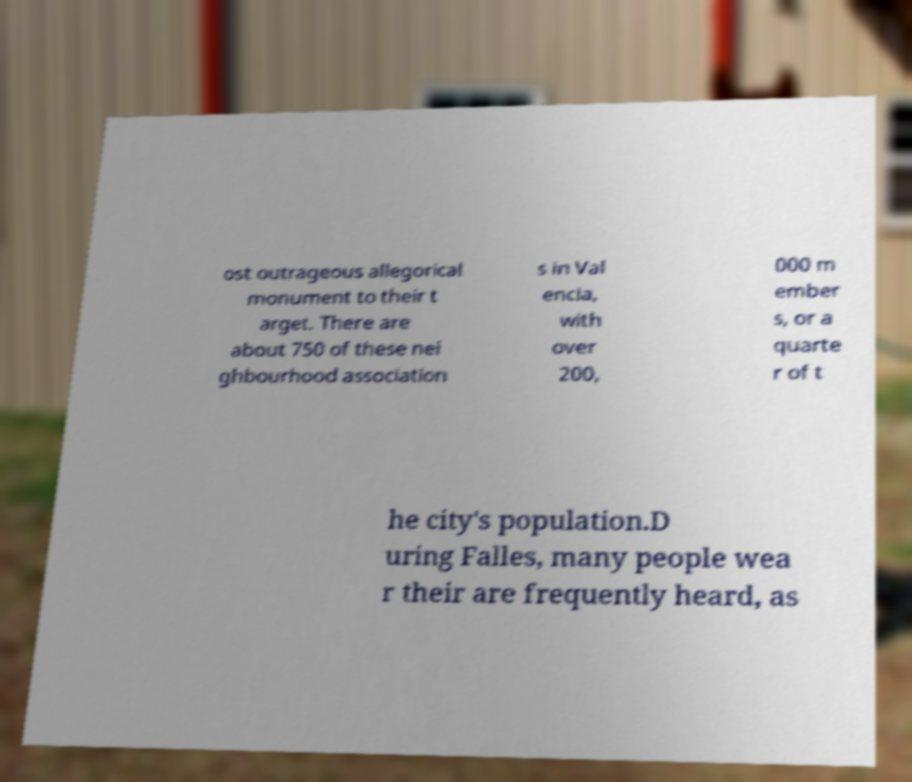Could you extract and type out the text from this image? ost outrageous allegorical monument to their t arget. There are about 750 of these nei ghbourhood association s in Val encia, with over 200, 000 m ember s, or a quarte r of t he city's population.D uring Falles, many people wea r their are frequently heard, as 